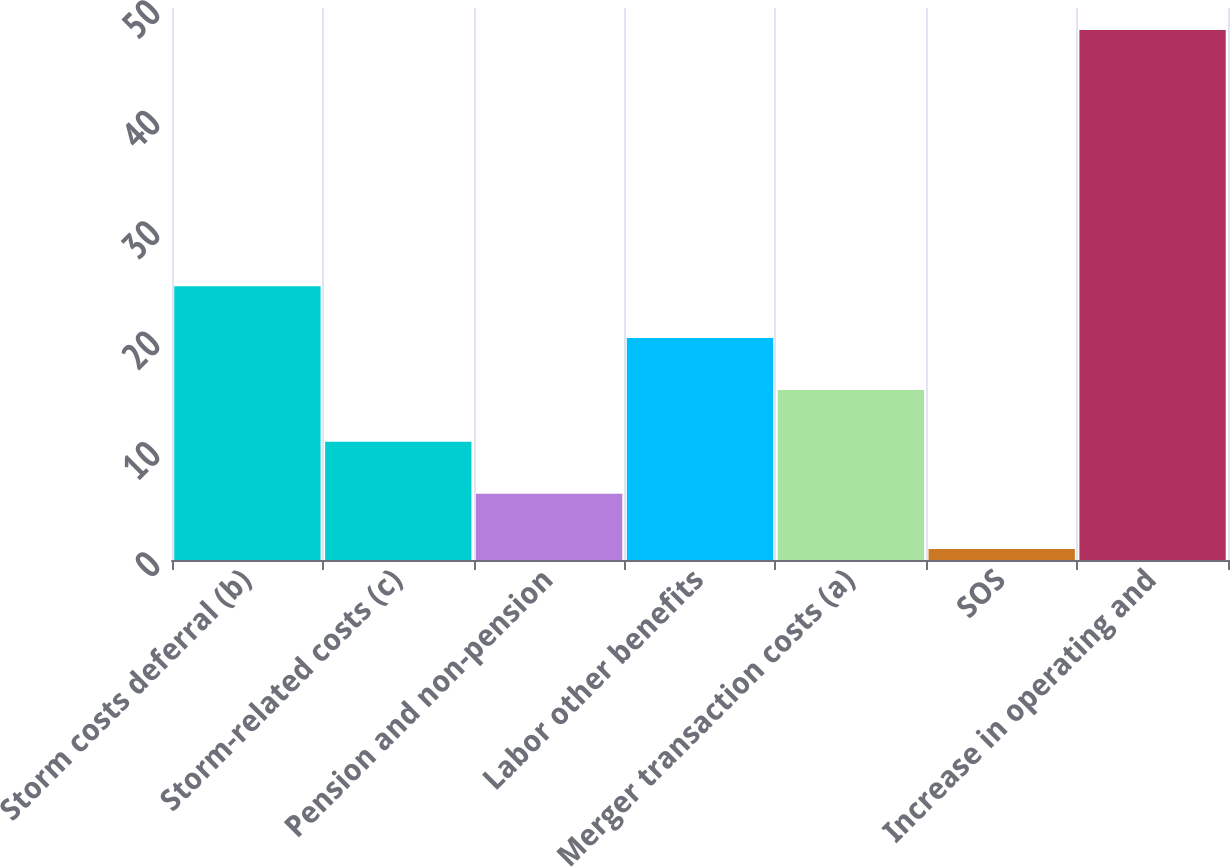Convert chart to OTSL. <chart><loc_0><loc_0><loc_500><loc_500><bar_chart><fcel>Storm costs deferral (b)<fcel>Storm-related costs (c)<fcel>Pension and non-pension<fcel>Labor other benefits<fcel>Merger transaction costs (a)<fcel>SOS<fcel>Increase in operating and<nl><fcel>24.8<fcel>10.7<fcel>6<fcel>20.1<fcel>15.4<fcel>1<fcel>48<nl></chart> 